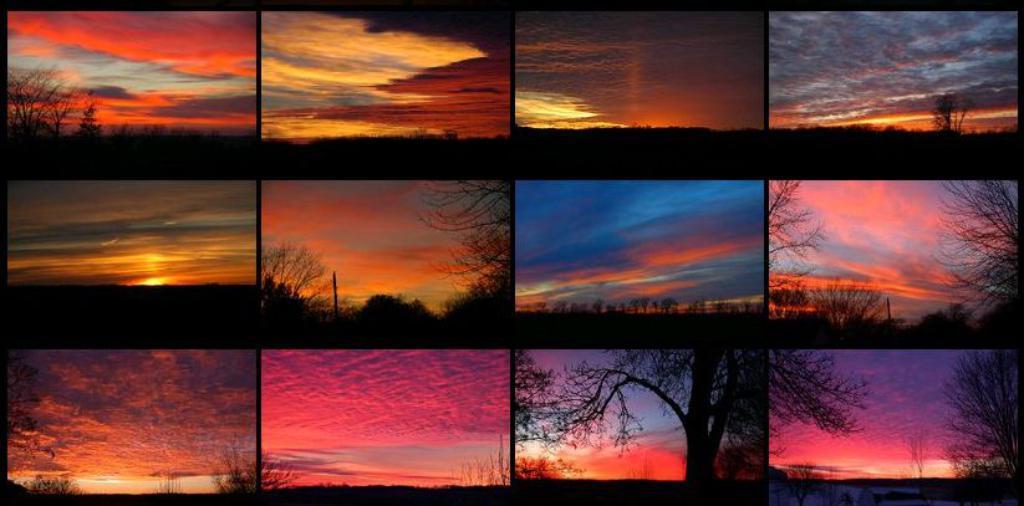Please provide a concise description of this image. This picture describes about collage of pictures, in this we can find trees and clouds. 